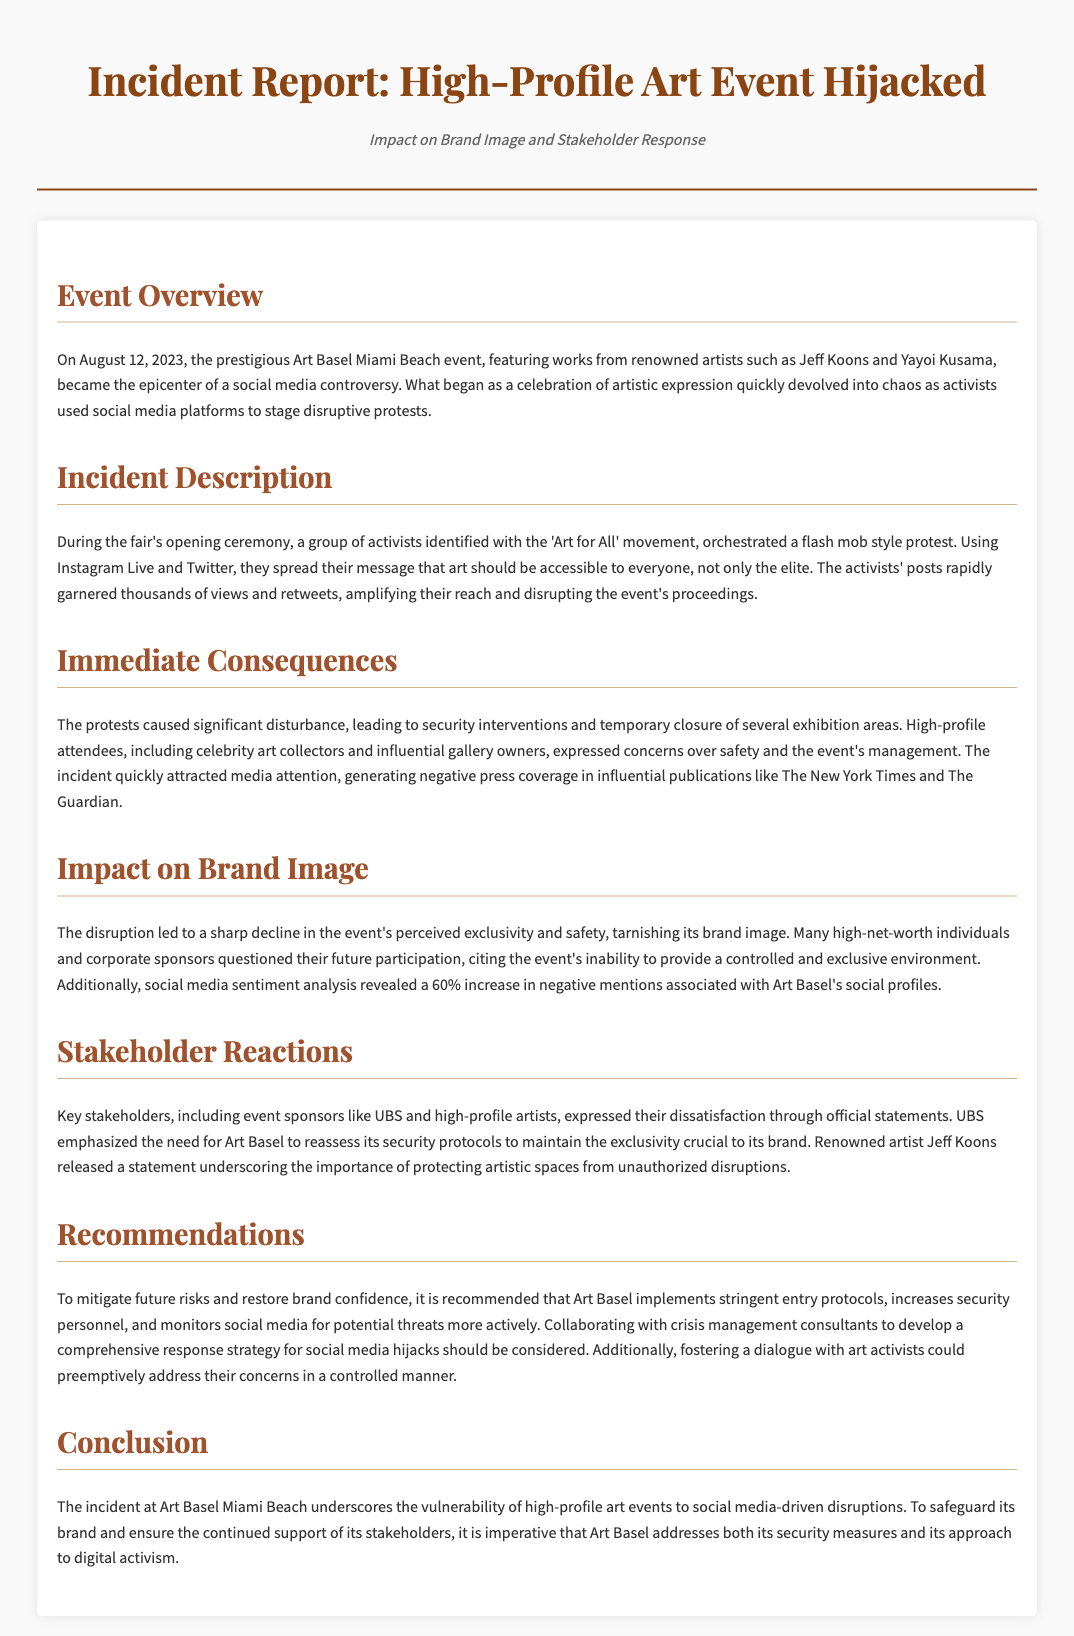What was the date of the event? The event took place on August 12, 2023.
Answer: August 12, 2023 Who were two featured artists at the event? The artists highlighted in the report include Jeff Koons and Yayoi Kusama.
Answer: Jeff Koons and Yayoi Kusama What was the name of the activist movement involved? The activists identified themselves with the 'Art for All' movement.
Answer: Art for All What was the increase in negative mentions associated with Art Basel? The report indicates a 60% increase in negative mentions.
Answer: 60% What did UBS emphasize in their statement? UBS highlighted the need for Art Basel to reassess its security protocols.
Answer: Reassess security protocols What kind of protest did the activists stage? The activists orchestrated a flash mob style protest.
Answer: Flash mob style protest What is one recommendation made to Art Basel? One recommendation is to implement stringent entry protocols.
Answer: Stringent entry protocols How did the immediate consequences of the protest manifest? The protests caused significant disturbance, leading to security interventions.
Answer: Security interventions What sentiment analysis was conducted regarding social media? Social media sentiment analysis was performed, revealing negative mentions.
Answer: Negative mentions 